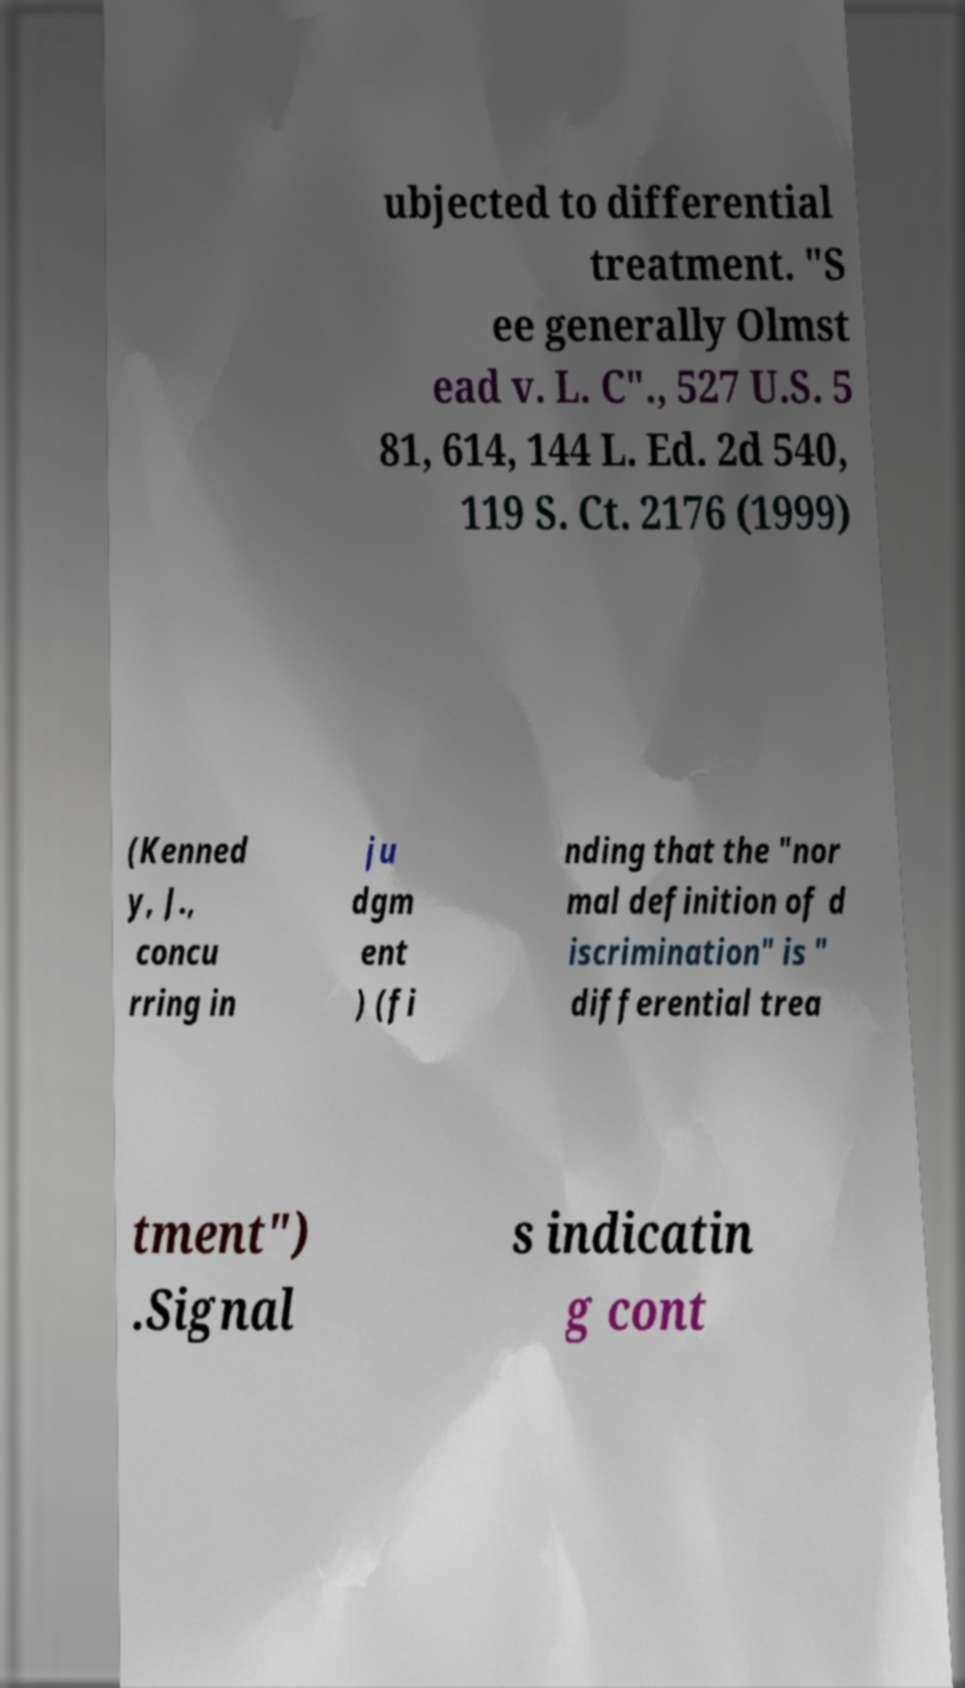I need the written content from this picture converted into text. Can you do that? ubjected to differential treatment. "S ee generally Olmst ead v. L. C"., 527 U.S. 5 81, 614, 144 L. Ed. 2d 540, 119 S. Ct. 2176 (1999) (Kenned y, J., concu rring in ju dgm ent ) (fi nding that the "nor mal definition of d iscrimination" is " differential trea tment") .Signal s indicatin g cont 